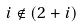<formula> <loc_0><loc_0><loc_500><loc_500>i \notin ( 2 + i )</formula> 